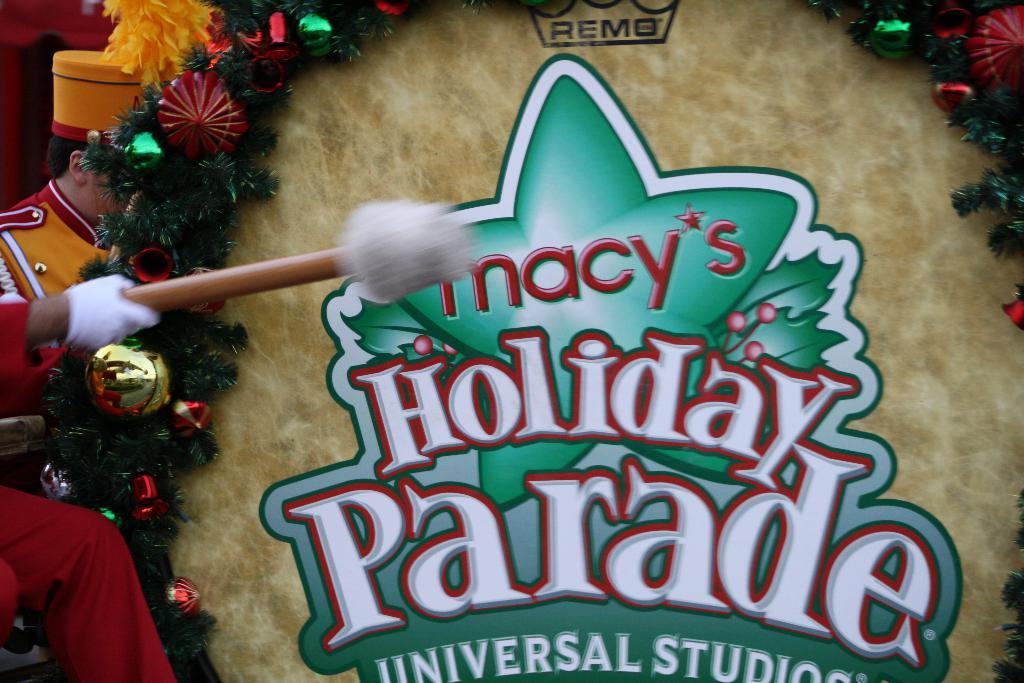How many people are in the image? There are people in the image, but the exact number is not specified. What is one person doing in the image? One person is holding a stick in the image. What can be seen in front of the person holding the stick? There are decorative items in front of the person holding the stick. What is the scent of the giraffe in the image? There is no giraffe present in the image, so it is not possible to determine its scent. 